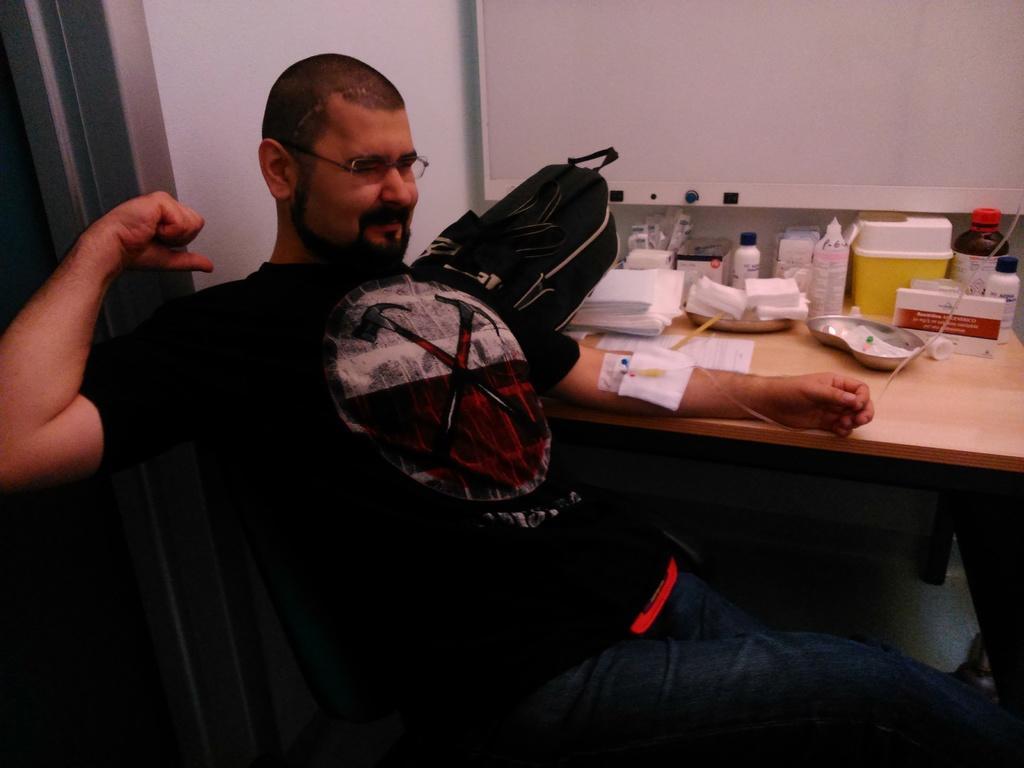Describe this image in one or two sentences. In this image we can see one man sitting on the chair, one red color object on the manś lap, one bag on the table, some objects on the table, one whiteboard attached to the wall, one injection with plaster and wire attached to the manś hand. Bottom of the image is dark. 